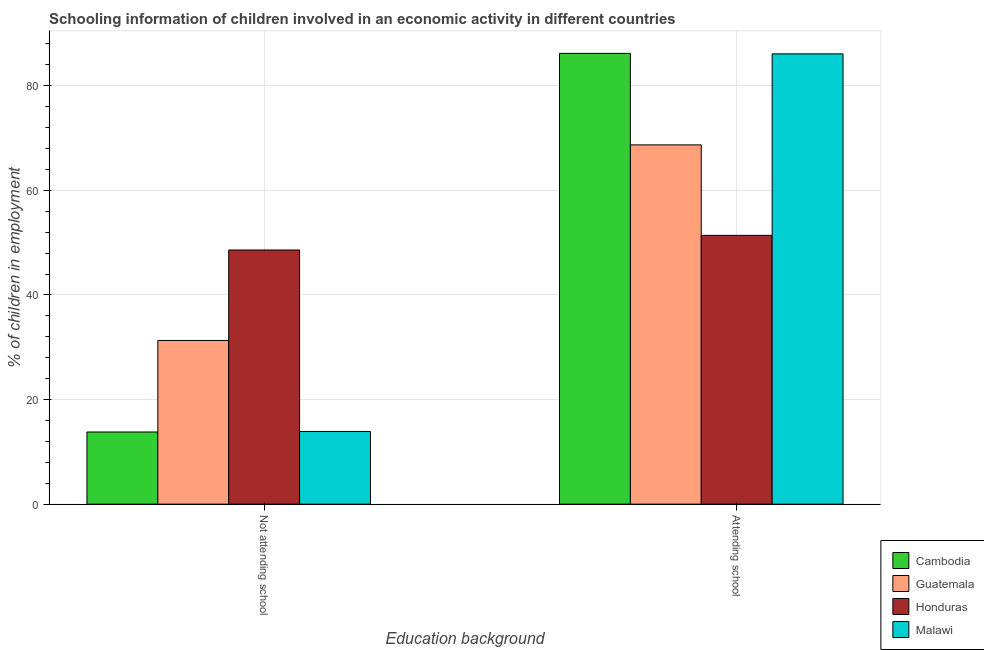How many groups of bars are there?
Your response must be concise. 2. How many bars are there on the 2nd tick from the left?
Give a very brief answer. 4. How many bars are there on the 2nd tick from the right?
Offer a very short reply. 4. What is the label of the 2nd group of bars from the left?
Offer a terse response. Attending school. What is the percentage of employed children who are attending school in Cambodia?
Ensure brevity in your answer.  86.2. Across all countries, what is the maximum percentage of employed children who are attending school?
Provide a short and direct response. 86.2. Across all countries, what is the minimum percentage of employed children who are attending school?
Ensure brevity in your answer.  51.4. In which country was the percentage of employed children who are attending school maximum?
Your response must be concise. Cambodia. In which country was the percentage of employed children who are attending school minimum?
Provide a short and direct response. Honduras. What is the total percentage of employed children who are attending school in the graph?
Provide a short and direct response. 292.4. What is the difference between the percentage of employed children who are attending school in Guatemala and that in Cambodia?
Offer a very short reply. -17.5. What is the difference between the percentage of employed children who are not attending school in Malawi and the percentage of employed children who are attending school in Guatemala?
Make the answer very short. -54.8. What is the average percentage of employed children who are attending school per country?
Offer a terse response. 73.1. What is the difference between the percentage of employed children who are attending school and percentage of employed children who are not attending school in Cambodia?
Make the answer very short. 72.4. In how many countries, is the percentage of employed children who are attending school greater than 40 %?
Your answer should be very brief. 4. What is the ratio of the percentage of employed children who are not attending school in Malawi to that in Honduras?
Your answer should be very brief. 0.29. In how many countries, is the percentage of employed children who are attending school greater than the average percentage of employed children who are attending school taken over all countries?
Offer a terse response. 2. What does the 1st bar from the left in Attending school represents?
Your answer should be very brief. Cambodia. What does the 4th bar from the right in Attending school represents?
Give a very brief answer. Cambodia. How many bars are there?
Offer a very short reply. 8. How many countries are there in the graph?
Offer a terse response. 4. Are the values on the major ticks of Y-axis written in scientific E-notation?
Offer a very short reply. No. Does the graph contain any zero values?
Provide a succinct answer. No. Does the graph contain grids?
Provide a succinct answer. Yes. What is the title of the graph?
Give a very brief answer. Schooling information of children involved in an economic activity in different countries. Does "New Zealand" appear as one of the legend labels in the graph?
Offer a terse response. No. What is the label or title of the X-axis?
Your response must be concise. Education background. What is the label or title of the Y-axis?
Provide a short and direct response. % of children in employment. What is the % of children in employment of Cambodia in Not attending school?
Your answer should be very brief. 13.8. What is the % of children in employment in Guatemala in Not attending school?
Your response must be concise. 31.3. What is the % of children in employment in Honduras in Not attending school?
Offer a very short reply. 48.6. What is the % of children in employment in Malawi in Not attending school?
Ensure brevity in your answer.  13.9. What is the % of children in employment of Cambodia in Attending school?
Keep it short and to the point. 86.2. What is the % of children in employment of Guatemala in Attending school?
Your answer should be very brief. 68.7. What is the % of children in employment of Honduras in Attending school?
Offer a terse response. 51.4. What is the % of children in employment in Malawi in Attending school?
Your answer should be compact. 86.1. Across all Education background, what is the maximum % of children in employment of Cambodia?
Ensure brevity in your answer.  86.2. Across all Education background, what is the maximum % of children in employment of Guatemala?
Keep it short and to the point. 68.7. Across all Education background, what is the maximum % of children in employment of Honduras?
Provide a short and direct response. 51.4. Across all Education background, what is the maximum % of children in employment of Malawi?
Give a very brief answer. 86.1. Across all Education background, what is the minimum % of children in employment in Cambodia?
Keep it short and to the point. 13.8. Across all Education background, what is the minimum % of children in employment in Guatemala?
Offer a terse response. 31.3. Across all Education background, what is the minimum % of children in employment in Honduras?
Keep it short and to the point. 48.6. Across all Education background, what is the minimum % of children in employment in Malawi?
Give a very brief answer. 13.9. What is the total % of children in employment in Cambodia in the graph?
Your answer should be very brief. 100. What is the total % of children in employment of Honduras in the graph?
Give a very brief answer. 100. What is the total % of children in employment in Malawi in the graph?
Your response must be concise. 100. What is the difference between the % of children in employment in Cambodia in Not attending school and that in Attending school?
Offer a very short reply. -72.4. What is the difference between the % of children in employment of Guatemala in Not attending school and that in Attending school?
Your response must be concise. -37.4. What is the difference between the % of children in employment in Honduras in Not attending school and that in Attending school?
Your answer should be compact. -2.8. What is the difference between the % of children in employment of Malawi in Not attending school and that in Attending school?
Your answer should be very brief. -72.2. What is the difference between the % of children in employment of Cambodia in Not attending school and the % of children in employment of Guatemala in Attending school?
Your answer should be very brief. -54.9. What is the difference between the % of children in employment of Cambodia in Not attending school and the % of children in employment of Honduras in Attending school?
Offer a terse response. -37.6. What is the difference between the % of children in employment of Cambodia in Not attending school and the % of children in employment of Malawi in Attending school?
Keep it short and to the point. -72.3. What is the difference between the % of children in employment in Guatemala in Not attending school and the % of children in employment in Honduras in Attending school?
Provide a succinct answer. -20.1. What is the difference between the % of children in employment of Guatemala in Not attending school and the % of children in employment of Malawi in Attending school?
Offer a terse response. -54.8. What is the difference between the % of children in employment of Honduras in Not attending school and the % of children in employment of Malawi in Attending school?
Keep it short and to the point. -37.5. What is the average % of children in employment of Cambodia per Education background?
Give a very brief answer. 50. What is the average % of children in employment of Guatemala per Education background?
Provide a succinct answer. 50. What is the difference between the % of children in employment of Cambodia and % of children in employment of Guatemala in Not attending school?
Offer a terse response. -17.5. What is the difference between the % of children in employment in Cambodia and % of children in employment in Honduras in Not attending school?
Your answer should be compact. -34.8. What is the difference between the % of children in employment in Cambodia and % of children in employment in Malawi in Not attending school?
Your response must be concise. -0.1. What is the difference between the % of children in employment of Guatemala and % of children in employment of Honduras in Not attending school?
Your answer should be very brief. -17.3. What is the difference between the % of children in employment in Guatemala and % of children in employment in Malawi in Not attending school?
Your response must be concise. 17.4. What is the difference between the % of children in employment of Honduras and % of children in employment of Malawi in Not attending school?
Keep it short and to the point. 34.7. What is the difference between the % of children in employment of Cambodia and % of children in employment of Honduras in Attending school?
Provide a succinct answer. 34.8. What is the difference between the % of children in employment in Guatemala and % of children in employment in Honduras in Attending school?
Ensure brevity in your answer.  17.3. What is the difference between the % of children in employment in Guatemala and % of children in employment in Malawi in Attending school?
Ensure brevity in your answer.  -17.4. What is the difference between the % of children in employment in Honduras and % of children in employment in Malawi in Attending school?
Make the answer very short. -34.7. What is the ratio of the % of children in employment of Cambodia in Not attending school to that in Attending school?
Ensure brevity in your answer.  0.16. What is the ratio of the % of children in employment of Guatemala in Not attending school to that in Attending school?
Keep it short and to the point. 0.46. What is the ratio of the % of children in employment in Honduras in Not attending school to that in Attending school?
Provide a short and direct response. 0.95. What is the ratio of the % of children in employment of Malawi in Not attending school to that in Attending school?
Provide a succinct answer. 0.16. What is the difference between the highest and the second highest % of children in employment of Cambodia?
Offer a terse response. 72.4. What is the difference between the highest and the second highest % of children in employment in Guatemala?
Your response must be concise. 37.4. What is the difference between the highest and the second highest % of children in employment in Honduras?
Offer a terse response. 2.8. What is the difference between the highest and the second highest % of children in employment in Malawi?
Offer a terse response. 72.2. What is the difference between the highest and the lowest % of children in employment of Cambodia?
Offer a very short reply. 72.4. What is the difference between the highest and the lowest % of children in employment in Guatemala?
Your answer should be very brief. 37.4. What is the difference between the highest and the lowest % of children in employment in Malawi?
Your answer should be very brief. 72.2. 